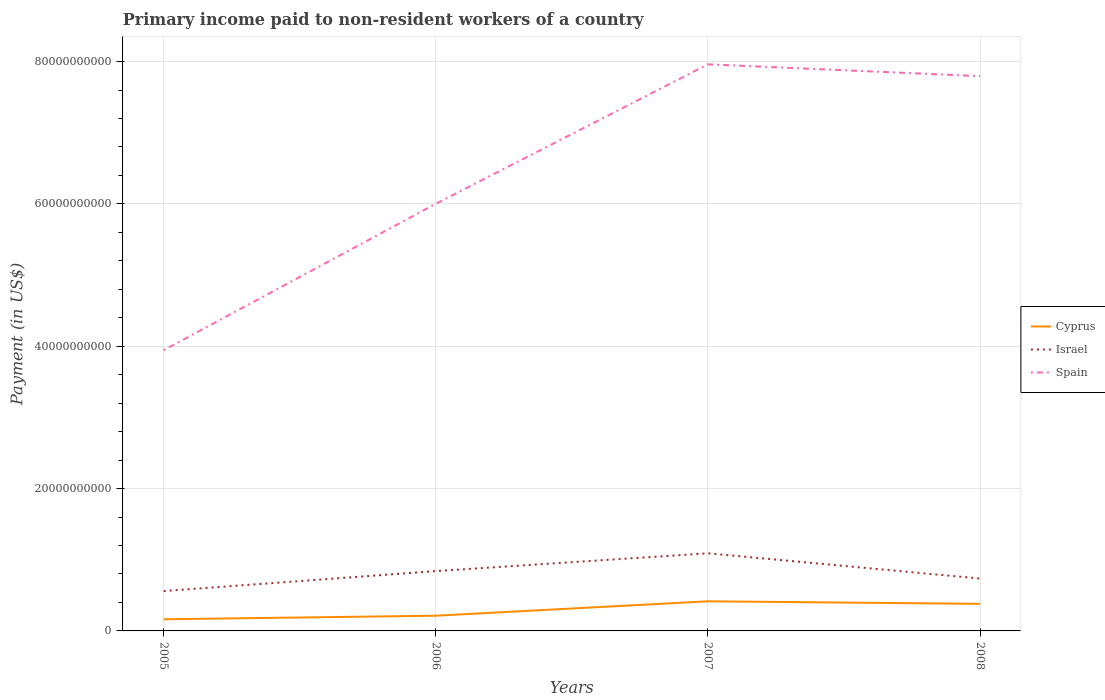Is the number of lines equal to the number of legend labels?
Provide a succinct answer. Yes. Across all years, what is the maximum amount paid to workers in Spain?
Your answer should be very brief. 3.94e+1. In which year was the amount paid to workers in Israel maximum?
Offer a terse response. 2005. What is the total amount paid to workers in Spain in the graph?
Offer a very short reply. -3.85e+1. What is the difference between the highest and the second highest amount paid to workers in Cyprus?
Your answer should be compact. 2.53e+09. Is the amount paid to workers in Cyprus strictly greater than the amount paid to workers in Spain over the years?
Keep it short and to the point. Yes. How many years are there in the graph?
Your answer should be very brief. 4. What is the difference between two consecutive major ticks on the Y-axis?
Your answer should be compact. 2.00e+1. Does the graph contain any zero values?
Your answer should be compact. No. How many legend labels are there?
Offer a terse response. 3. What is the title of the graph?
Give a very brief answer. Primary income paid to non-resident workers of a country. Does "Aruba" appear as one of the legend labels in the graph?
Offer a terse response. No. What is the label or title of the Y-axis?
Keep it short and to the point. Payment (in US$). What is the Payment (in US$) of Cyprus in 2005?
Offer a very short reply. 1.63e+09. What is the Payment (in US$) in Israel in 2005?
Provide a short and direct response. 5.60e+09. What is the Payment (in US$) in Spain in 2005?
Give a very brief answer. 3.94e+1. What is the Payment (in US$) in Cyprus in 2006?
Make the answer very short. 2.14e+09. What is the Payment (in US$) of Israel in 2006?
Give a very brief answer. 8.41e+09. What is the Payment (in US$) of Spain in 2006?
Your response must be concise. 6.00e+1. What is the Payment (in US$) of Cyprus in 2007?
Your response must be concise. 4.16e+09. What is the Payment (in US$) in Israel in 2007?
Keep it short and to the point. 1.09e+1. What is the Payment (in US$) in Spain in 2007?
Give a very brief answer. 7.96e+1. What is the Payment (in US$) of Cyprus in 2008?
Your answer should be very brief. 3.81e+09. What is the Payment (in US$) in Israel in 2008?
Your answer should be compact. 7.36e+09. What is the Payment (in US$) in Spain in 2008?
Offer a very short reply. 7.80e+1. Across all years, what is the maximum Payment (in US$) in Cyprus?
Ensure brevity in your answer.  4.16e+09. Across all years, what is the maximum Payment (in US$) in Israel?
Your response must be concise. 1.09e+1. Across all years, what is the maximum Payment (in US$) in Spain?
Make the answer very short. 7.96e+1. Across all years, what is the minimum Payment (in US$) in Cyprus?
Your answer should be compact. 1.63e+09. Across all years, what is the minimum Payment (in US$) of Israel?
Ensure brevity in your answer.  5.60e+09. Across all years, what is the minimum Payment (in US$) in Spain?
Your answer should be very brief. 3.94e+1. What is the total Payment (in US$) of Cyprus in the graph?
Offer a very short reply. 1.17e+1. What is the total Payment (in US$) of Israel in the graph?
Ensure brevity in your answer.  3.23e+1. What is the total Payment (in US$) in Spain in the graph?
Provide a short and direct response. 2.57e+11. What is the difference between the Payment (in US$) in Cyprus in 2005 and that in 2006?
Your response must be concise. -5.04e+08. What is the difference between the Payment (in US$) in Israel in 2005 and that in 2006?
Your answer should be compact. -2.81e+09. What is the difference between the Payment (in US$) of Spain in 2005 and that in 2006?
Ensure brevity in your answer.  -2.06e+1. What is the difference between the Payment (in US$) of Cyprus in 2005 and that in 2007?
Keep it short and to the point. -2.53e+09. What is the difference between the Payment (in US$) in Israel in 2005 and that in 2007?
Offer a very short reply. -5.31e+09. What is the difference between the Payment (in US$) of Spain in 2005 and that in 2007?
Ensure brevity in your answer.  -4.02e+1. What is the difference between the Payment (in US$) of Cyprus in 2005 and that in 2008?
Provide a short and direct response. -2.17e+09. What is the difference between the Payment (in US$) of Israel in 2005 and that in 2008?
Provide a short and direct response. -1.76e+09. What is the difference between the Payment (in US$) in Spain in 2005 and that in 2008?
Provide a short and direct response. -3.85e+1. What is the difference between the Payment (in US$) of Cyprus in 2006 and that in 2007?
Your answer should be very brief. -2.02e+09. What is the difference between the Payment (in US$) in Israel in 2006 and that in 2007?
Make the answer very short. -2.50e+09. What is the difference between the Payment (in US$) of Spain in 2006 and that in 2007?
Offer a very short reply. -1.96e+1. What is the difference between the Payment (in US$) of Cyprus in 2006 and that in 2008?
Keep it short and to the point. -1.67e+09. What is the difference between the Payment (in US$) in Israel in 2006 and that in 2008?
Your response must be concise. 1.05e+09. What is the difference between the Payment (in US$) of Spain in 2006 and that in 2008?
Keep it short and to the point. -1.79e+1. What is the difference between the Payment (in US$) of Cyprus in 2007 and that in 2008?
Your response must be concise. 3.58e+08. What is the difference between the Payment (in US$) in Israel in 2007 and that in 2008?
Provide a succinct answer. 3.55e+09. What is the difference between the Payment (in US$) of Spain in 2007 and that in 2008?
Keep it short and to the point. 1.66e+09. What is the difference between the Payment (in US$) in Cyprus in 2005 and the Payment (in US$) in Israel in 2006?
Make the answer very short. -6.77e+09. What is the difference between the Payment (in US$) of Cyprus in 2005 and the Payment (in US$) of Spain in 2006?
Your answer should be compact. -5.84e+1. What is the difference between the Payment (in US$) in Israel in 2005 and the Payment (in US$) in Spain in 2006?
Offer a very short reply. -5.44e+1. What is the difference between the Payment (in US$) of Cyprus in 2005 and the Payment (in US$) of Israel in 2007?
Your answer should be very brief. -9.27e+09. What is the difference between the Payment (in US$) of Cyprus in 2005 and the Payment (in US$) of Spain in 2007?
Your answer should be compact. -7.80e+1. What is the difference between the Payment (in US$) in Israel in 2005 and the Payment (in US$) in Spain in 2007?
Your response must be concise. -7.40e+1. What is the difference between the Payment (in US$) in Cyprus in 2005 and the Payment (in US$) in Israel in 2008?
Provide a succinct answer. -5.72e+09. What is the difference between the Payment (in US$) in Cyprus in 2005 and the Payment (in US$) in Spain in 2008?
Provide a succinct answer. -7.63e+1. What is the difference between the Payment (in US$) of Israel in 2005 and the Payment (in US$) of Spain in 2008?
Give a very brief answer. -7.24e+1. What is the difference between the Payment (in US$) of Cyprus in 2006 and the Payment (in US$) of Israel in 2007?
Offer a very short reply. -8.77e+09. What is the difference between the Payment (in US$) in Cyprus in 2006 and the Payment (in US$) in Spain in 2007?
Keep it short and to the point. -7.75e+1. What is the difference between the Payment (in US$) of Israel in 2006 and the Payment (in US$) of Spain in 2007?
Ensure brevity in your answer.  -7.12e+1. What is the difference between the Payment (in US$) in Cyprus in 2006 and the Payment (in US$) in Israel in 2008?
Your answer should be compact. -5.22e+09. What is the difference between the Payment (in US$) in Cyprus in 2006 and the Payment (in US$) in Spain in 2008?
Ensure brevity in your answer.  -7.58e+1. What is the difference between the Payment (in US$) of Israel in 2006 and the Payment (in US$) of Spain in 2008?
Your answer should be compact. -6.95e+1. What is the difference between the Payment (in US$) of Cyprus in 2007 and the Payment (in US$) of Israel in 2008?
Offer a terse response. -3.20e+09. What is the difference between the Payment (in US$) of Cyprus in 2007 and the Payment (in US$) of Spain in 2008?
Offer a terse response. -7.38e+1. What is the difference between the Payment (in US$) in Israel in 2007 and the Payment (in US$) in Spain in 2008?
Make the answer very short. -6.70e+1. What is the average Payment (in US$) of Cyprus per year?
Offer a very short reply. 2.94e+09. What is the average Payment (in US$) of Israel per year?
Ensure brevity in your answer.  8.07e+09. What is the average Payment (in US$) in Spain per year?
Your response must be concise. 6.43e+1. In the year 2005, what is the difference between the Payment (in US$) of Cyprus and Payment (in US$) of Israel?
Provide a short and direct response. -3.97e+09. In the year 2005, what is the difference between the Payment (in US$) in Cyprus and Payment (in US$) in Spain?
Give a very brief answer. -3.78e+1. In the year 2005, what is the difference between the Payment (in US$) in Israel and Payment (in US$) in Spain?
Your answer should be very brief. -3.38e+1. In the year 2006, what is the difference between the Payment (in US$) in Cyprus and Payment (in US$) in Israel?
Keep it short and to the point. -6.27e+09. In the year 2006, what is the difference between the Payment (in US$) of Cyprus and Payment (in US$) of Spain?
Your answer should be compact. -5.79e+1. In the year 2006, what is the difference between the Payment (in US$) in Israel and Payment (in US$) in Spain?
Offer a very short reply. -5.16e+1. In the year 2007, what is the difference between the Payment (in US$) in Cyprus and Payment (in US$) in Israel?
Make the answer very short. -6.74e+09. In the year 2007, what is the difference between the Payment (in US$) in Cyprus and Payment (in US$) in Spain?
Your response must be concise. -7.55e+1. In the year 2007, what is the difference between the Payment (in US$) of Israel and Payment (in US$) of Spain?
Your answer should be very brief. -6.87e+1. In the year 2008, what is the difference between the Payment (in US$) of Cyprus and Payment (in US$) of Israel?
Your answer should be very brief. -3.55e+09. In the year 2008, what is the difference between the Payment (in US$) in Cyprus and Payment (in US$) in Spain?
Offer a very short reply. -7.41e+1. In the year 2008, what is the difference between the Payment (in US$) of Israel and Payment (in US$) of Spain?
Give a very brief answer. -7.06e+1. What is the ratio of the Payment (in US$) in Cyprus in 2005 to that in 2006?
Keep it short and to the point. 0.76. What is the ratio of the Payment (in US$) of Israel in 2005 to that in 2006?
Keep it short and to the point. 0.67. What is the ratio of the Payment (in US$) in Spain in 2005 to that in 2006?
Provide a succinct answer. 0.66. What is the ratio of the Payment (in US$) in Cyprus in 2005 to that in 2007?
Offer a terse response. 0.39. What is the ratio of the Payment (in US$) in Israel in 2005 to that in 2007?
Make the answer very short. 0.51. What is the ratio of the Payment (in US$) in Spain in 2005 to that in 2007?
Ensure brevity in your answer.  0.5. What is the ratio of the Payment (in US$) in Cyprus in 2005 to that in 2008?
Your answer should be very brief. 0.43. What is the ratio of the Payment (in US$) of Israel in 2005 to that in 2008?
Give a very brief answer. 0.76. What is the ratio of the Payment (in US$) in Spain in 2005 to that in 2008?
Offer a very short reply. 0.51. What is the ratio of the Payment (in US$) of Cyprus in 2006 to that in 2007?
Ensure brevity in your answer.  0.51. What is the ratio of the Payment (in US$) in Israel in 2006 to that in 2007?
Your answer should be very brief. 0.77. What is the ratio of the Payment (in US$) of Spain in 2006 to that in 2007?
Your answer should be very brief. 0.75. What is the ratio of the Payment (in US$) in Cyprus in 2006 to that in 2008?
Provide a short and direct response. 0.56. What is the ratio of the Payment (in US$) in Israel in 2006 to that in 2008?
Keep it short and to the point. 1.14. What is the ratio of the Payment (in US$) of Spain in 2006 to that in 2008?
Your answer should be compact. 0.77. What is the ratio of the Payment (in US$) in Cyprus in 2007 to that in 2008?
Keep it short and to the point. 1.09. What is the ratio of the Payment (in US$) in Israel in 2007 to that in 2008?
Keep it short and to the point. 1.48. What is the ratio of the Payment (in US$) in Spain in 2007 to that in 2008?
Give a very brief answer. 1.02. What is the difference between the highest and the second highest Payment (in US$) in Cyprus?
Offer a terse response. 3.58e+08. What is the difference between the highest and the second highest Payment (in US$) of Israel?
Provide a succinct answer. 2.50e+09. What is the difference between the highest and the second highest Payment (in US$) in Spain?
Your response must be concise. 1.66e+09. What is the difference between the highest and the lowest Payment (in US$) in Cyprus?
Offer a terse response. 2.53e+09. What is the difference between the highest and the lowest Payment (in US$) in Israel?
Your answer should be very brief. 5.31e+09. What is the difference between the highest and the lowest Payment (in US$) of Spain?
Make the answer very short. 4.02e+1. 